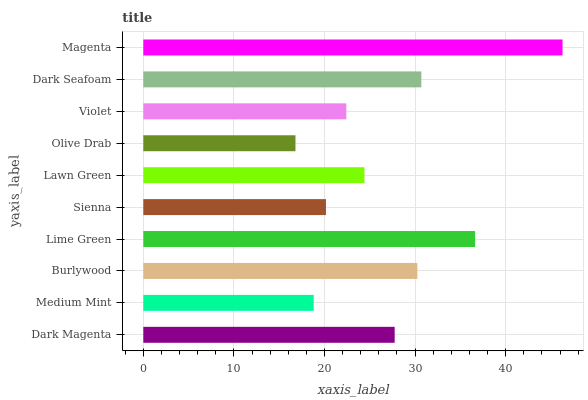Is Olive Drab the minimum?
Answer yes or no. Yes. Is Magenta the maximum?
Answer yes or no. Yes. Is Medium Mint the minimum?
Answer yes or no. No. Is Medium Mint the maximum?
Answer yes or no. No. Is Dark Magenta greater than Medium Mint?
Answer yes or no. Yes. Is Medium Mint less than Dark Magenta?
Answer yes or no. Yes. Is Medium Mint greater than Dark Magenta?
Answer yes or no. No. Is Dark Magenta less than Medium Mint?
Answer yes or no. No. Is Dark Magenta the high median?
Answer yes or no. Yes. Is Lawn Green the low median?
Answer yes or no. Yes. Is Medium Mint the high median?
Answer yes or no. No. Is Magenta the low median?
Answer yes or no. No. 